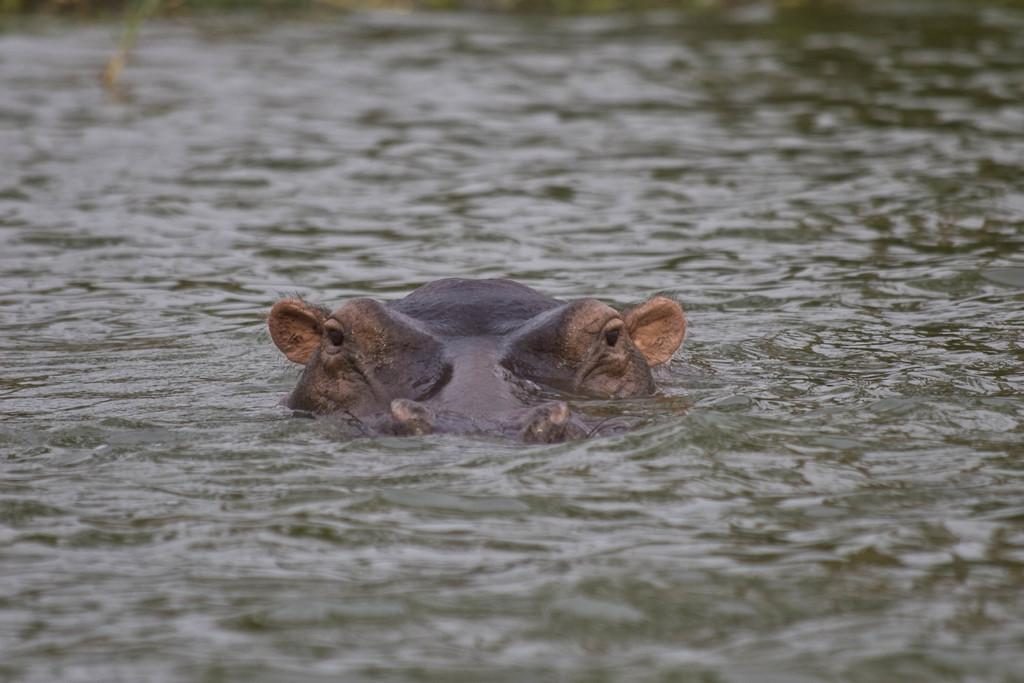What type of animal can be seen in the image? There is an animal in the image, but its specific type cannot be determined from the provided facts. Where is the animal located in the image? The animal is in water in the image. What can be observed about the water's surface in the image? There are ripples in the water. What type of sheet is covering the animal in the image? There is no sheet present in the image; the animal is in water with ripples on the surface. How many pies are visible in the image? There are no pies present in the image. 